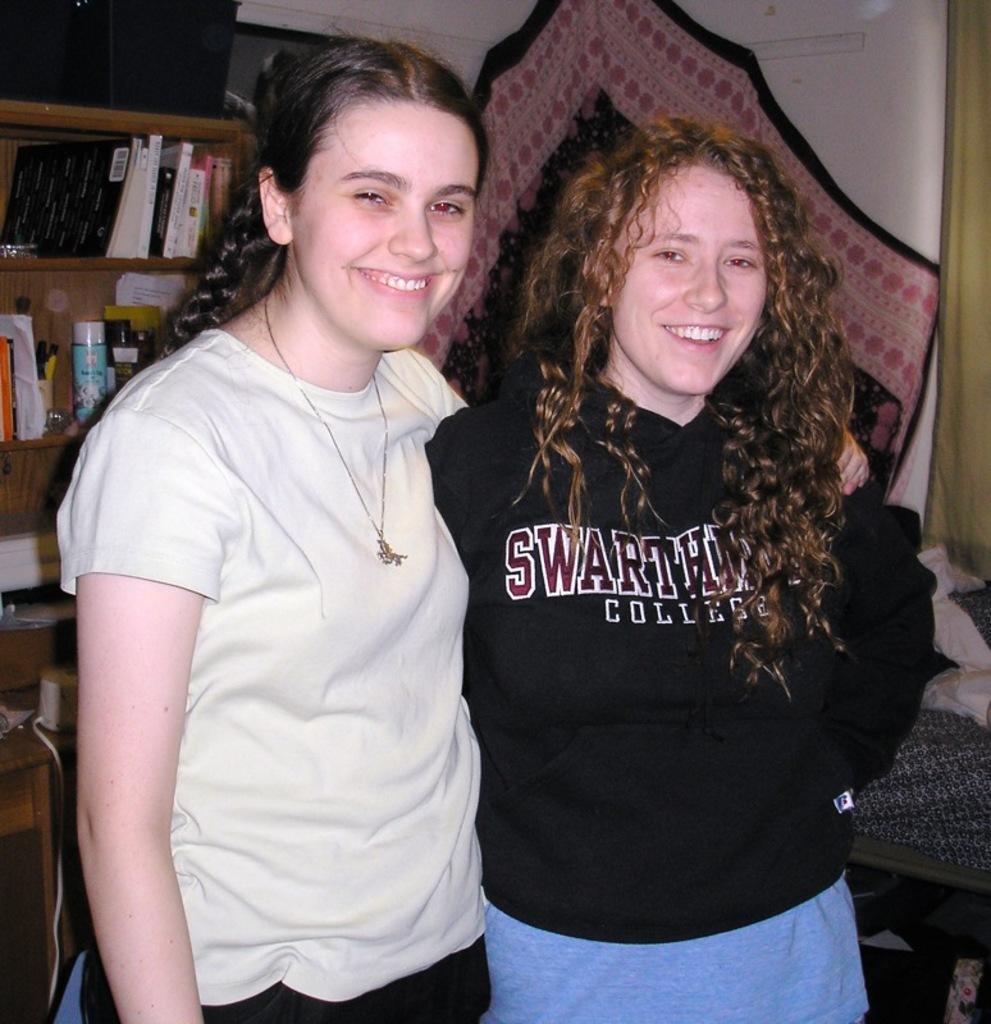Describe this image in one or two sentences. In this picture there are two women standing and smiling. In the background of the image we can see clothes, books and objects in racks, wall, device and objects. 